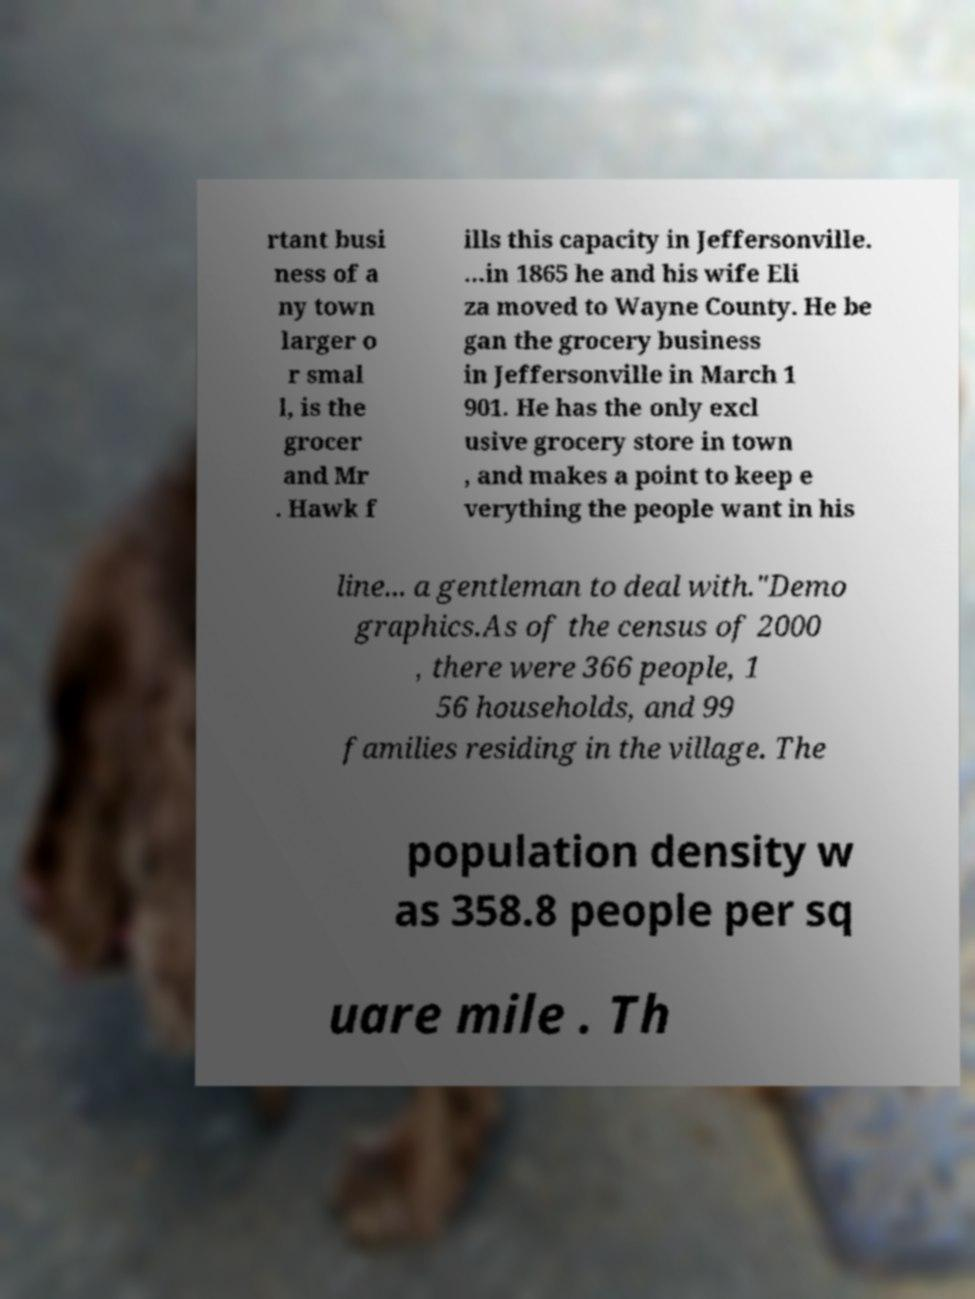There's text embedded in this image that I need extracted. Can you transcribe it verbatim? rtant busi ness of a ny town larger o r smal l, is the grocer and Mr . Hawk f ills this capacity in Jeffersonville. ...in 1865 he and his wife Eli za moved to Wayne County. He be gan the grocery business in Jeffersonville in March 1 901. He has the only excl usive grocery store in town , and makes a point to keep e verything the people want in his line... a gentleman to deal with."Demo graphics.As of the census of 2000 , there were 366 people, 1 56 households, and 99 families residing in the village. The population density w as 358.8 people per sq uare mile . Th 